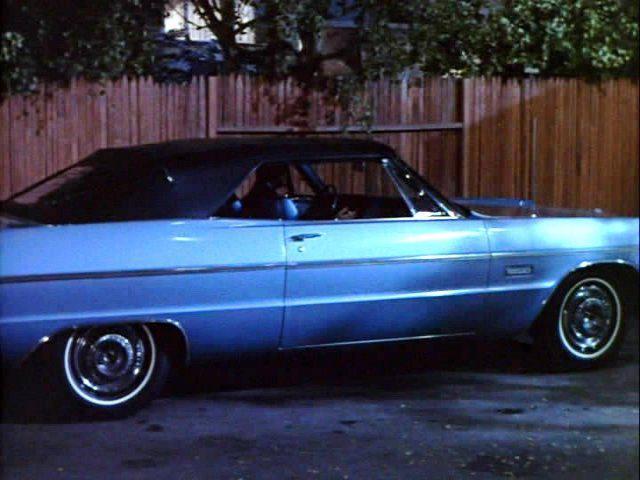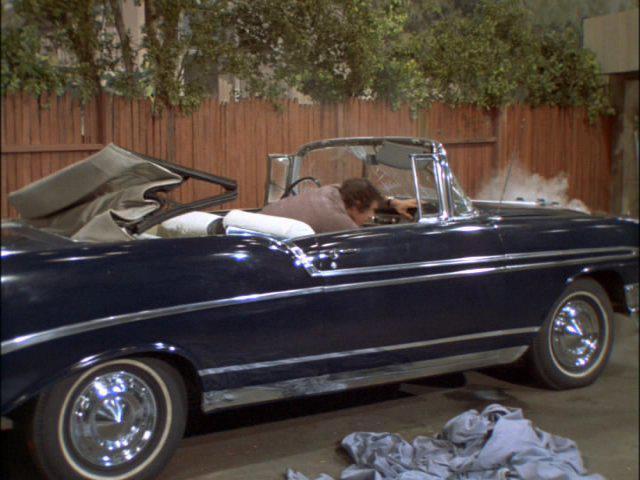The first image is the image on the left, the second image is the image on the right. Given the left and right images, does the statement "There is one convertible driving down the road facing left." hold true? Answer yes or no. No. The first image is the image on the left, the second image is the image on the right. For the images displayed, is the sentence "There is a convertible in each photo with it's top down" factually correct? Answer yes or no. No. 